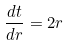Convert formula to latex. <formula><loc_0><loc_0><loc_500><loc_500>\frac { d t } { d r } = 2 r</formula> 